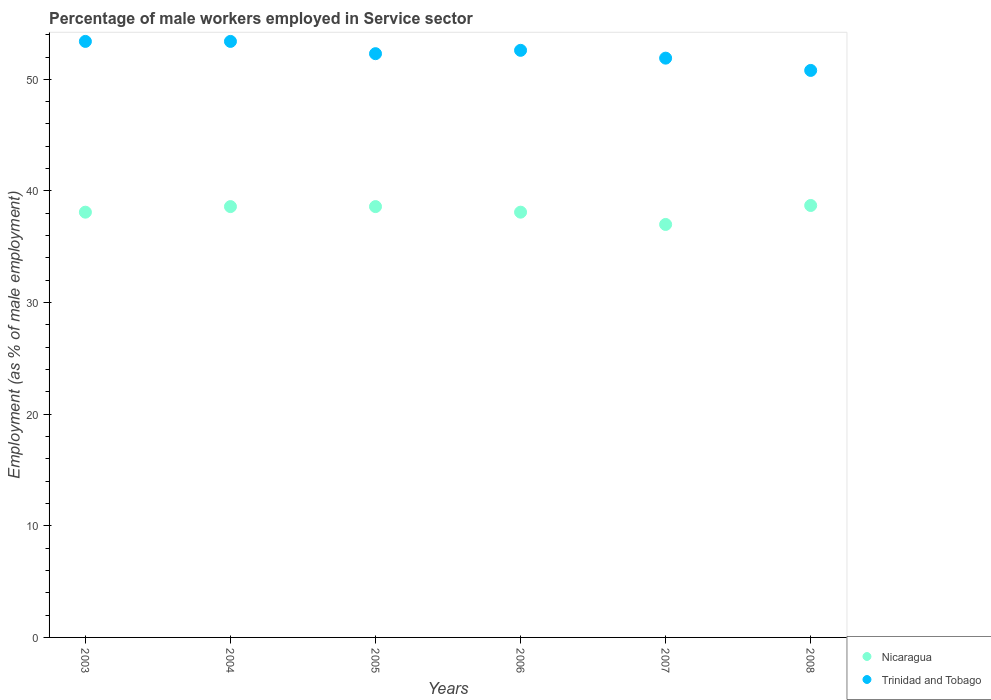How many different coloured dotlines are there?
Provide a succinct answer. 2. Across all years, what is the maximum percentage of male workers employed in Service sector in Nicaragua?
Keep it short and to the point. 38.7. Across all years, what is the minimum percentage of male workers employed in Service sector in Trinidad and Tobago?
Your answer should be compact. 50.8. In which year was the percentage of male workers employed in Service sector in Trinidad and Tobago maximum?
Ensure brevity in your answer.  2003. In which year was the percentage of male workers employed in Service sector in Nicaragua minimum?
Ensure brevity in your answer.  2007. What is the total percentage of male workers employed in Service sector in Trinidad and Tobago in the graph?
Give a very brief answer. 314.4. What is the difference between the percentage of male workers employed in Service sector in Trinidad and Tobago in 2004 and that in 2006?
Keep it short and to the point. 0.8. What is the average percentage of male workers employed in Service sector in Nicaragua per year?
Your response must be concise. 38.18. In the year 2008, what is the difference between the percentage of male workers employed in Service sector in Trinidad and Tobago and percentage of male workers employed in Service sector in Nicaragua?
Ensure brevity in your answer.  12.1. What is the ratio of the percentage of male workers employed in Service sector in Trinidad and Tobago in 2007 to that in 2008?
Your answer should be very brief. 1.02. What is the difference between the highest and the second highest percentage of male workers employed in Service sector in Trinidad and Tobago?
Your answer should be compact. 0. What is the difference between the highest and the lowest percentage of male workers employed in Service sector in Nicaragua?
Ensure brevity in your answer.  1.7. Does the percentage of male workers employed in Service sector in Nicaragua monotonically increase over the years?
Offer a very short reply. No. What is the difference between two consecutive major ticks on the Y-axis?
Your answer should be very brief. 10. How are the legend labels stacked?
Keep it short and to the point. Vertical. What is the title of the graph?
Your answer should be compact. Percentage of male workers employed in Service sector. What is the label or title of the X-axis?
Provide a succinct answer. Years. What is the label or title of the Y-axis?
Offer a terse response. Employment (as % of male employment). What is the Employment (as % of male employment) in Nicaragua in 2003?
Offer a terse response. 38.1. What is the Employment (as % of male employment) in Trinidad and Tobago in 2003?
Make the answer very short. 53.4. What is the Employment (as % of male employment) of Nicaragua in 2004?
Make the answer very short. 38.6. What is the Employment (as % of male employment) of Trinidad and Tobago in 2004?
Offer a terse response. 53.4. What is the Employment (as % of male employment) of Nicaragua in 2005?
Provide a short and direct response. 38.6. What is the Employment (as % of male employment) of Trinidad and Tobago in 2005?
Make the answer very short. 52.3. What is the Employment (as % of male employment) in Nicaragua in 2006?
Your answer should be compact. 38.1. What is the Employment (as % of male employment) in Trinidad and Tobago in 2006?
Make the answer very short. 52.6. What is the Employment (as % of male employment) in Nicaragua in 2007?
Your answer should be compact. 37. What is the Employment (as % of male employment) in Trinidad and Tobago in 2007?
Offer a terse response. 51.9. What is the Employment (as % of male employment) in Nicaragua in 2008?
Provide a short and direct response. 38.7. What is the Employment (as % of male employment) in Trinidad and Tobago in 2008?
Keep it short and to the point. 50.8. Across all years, what is the maximum Employment (as % of male employment) in Nicaragua?
Your response must be concise. 38.7. Across all years, what is the maximum Employment (as % of male employment) of Trinidad and Tobago?
Give a very brief answer. 53.4. Across all years, what is the minimum Employment (as % of male employment) of Nicaragua?
Offer a terse response. 37. Across all years, what is the minimum Employment (as % of male employment) of Trinidad and Tobago?
Make the answer very short. 50.8. What is the total Employment (as % of male employment) in Nicaragua in the graph?
Ensure brevity in your answer.  229.1. What is the total Employment (as % of male employment) in Trinidad and Tobago in the graph?
Your answer should be very brief. 314.4. What is the difference between the Employment (as % of male employment) in Trinidad and Tobago in 2003 and that in 2004?
Offer a terse response. 0. What is the difference between the Employment (as % of male employment) of Nicaragua in 2003 and that in 2005?
Your response must be concise. -0.5. What is the difference between the Employment (as % of male employment) in Trinidad and Tobago in 2003 and that in 2005?
Your answer should be compact. 1.1. What is the difference between the Employment (as % of male employment) of Nicaragua in 2003 and that in 2006?
Your answer should be very brief. 0. What is the difference between the Employment (as % of male employment) in Trinidad and Tobago in 2003 and that in 2006?
Provide a succinct answer. 0.8. What is the difference between the Employment (as % of male employment) in Nicaragua in 2003 and that in 2007?
Provide a succinct answer. 1.1. What is the difference between the Employment (as % of male employment) in Trinidad and Tobago in 2003 and that in 2007?
Your response must be concise. 1.5. What is the difference between the Employment (as % of male employment) in Trinidad and Tobago in 2003 and that in 2008?
Ensure brevity in your answer.  2.6. What is the difference between the Employment (as % of male employment) of Nicaragua in 2004 and that in 2005?
Offer a very short reply. 0. What is the difference between the Employment (as % of male employment) in Nicaragua in 2004 and that in 2006?
Your answer should be very brief. 0.5. What is the difference between the Employment (as % of male employment) of Trinidad and Tobago in 2004 and that in 2006?
Keep it short and to the point. 0.8. What is the difference between the Employment (as % of male employment) in Nicaragua in 2004 and that in 2007?
Provide a succinct answer. 1.6. What is the difference between the Employment (as % of male employment) in Trinidad and Tobago in 2004 and that in 2007?
Provide a short and direct response. 1.5. What is the difference between the Employment (as % of male employment) in Trinidad and Tobago in 2004 and that in 2008?
Your response must be concise. 2.6. What is the difference between the Employment (as % of male employment) of Trinidad and Tobago in 2005 and that in 2006?
Your response must be concise. -0.3. What is the difference between the Employment (as % of male employment) of Nicaragua in 2005 and that in 2007?
Offer a terse response. 1.6. What is the difference between the Employment (as % of male employment) of Nicaragua in 2005 and that in 2008?
Your response must be concise. -0.1. What is the difference between the Employment (as % of male employment) in Nicaragua in 2006 and that in 2007?
Keep it short and to the point. 1.1. What is the difference between the Employment (as % of male employment) in Nicaragua in 2006 and that in 2008?
Your answer should be very brief. -0.6. What is the difference between the Employment (as % of male employment) in Nicaragua in 2003 and the Employment (as % of male employment) in Trinidad and Tobago in 2004?
Offer a terse response. -15.3. What is the difference between the Employment (as % of male employment) of Nicaragua in 2003 and the Employment (as % of male employment) of Trinidad and Tobago in 2006?
Your response must be concise. -14.5. What is the difference between the Employment (as % of male employment) of Nicaragua in 2003 and the Employment (as % of male employment) of Trinidad and Tobago in 2007?
Give a very brief answer. -13.8. What is the difference between the Employment (as % of male employment) of Nicaragua in 2003 and the Employment (as % of male employment) of Trinidad and Tobago in 2008?
Provide a succinct answer. -12.7. What is the difference between the Employment (as % of male employment) of Nicaragua in 2004 and the Employment (as % of male employment) of Trinidad and Tobago in 2005?
Ensure brevity in your answer.  -13.7. What is the difference between the Employment (as % of male employment) of Nicaragua in 2004 and the Employment (as % of male employment) of Trinidad and Tobago in 2006?
Your response must be concise. -14. What is the difference between the Employment (as % of male employment) of Nicaragua in 2004 and the Employment (as % of male employment) of Trinidad and Tobago in 2007?
Give a very brief answer. -13.3. What is the difference between the Employment (as % of male employment) in Nicaragua in 2004 and the Employment (as % of male employment) in Trinidad and Tobago in 2008?
Ensure brevity in your answer.  -12.2. What is the difference between the Employment (as % of male employment) in Nicaragua in 2007 and the Employment (as % of male employment) in Trinidad and Tobago in 2008?
Offer a terse response. -13.8. What is the average Employment (as % of male employment) in Nicaragua per year?
Provide a short and direct response. 38.18. What is the average Employment (as % of male employment) in Trinidad and Tobago per year?
Make the answer very short. 52.4. In the year 2003, what is the difference between the Employment (as % of male employment) in Nicaragua and Employment (as % of male employment) in Trinidad and Tobago?
Provide a succinct answer. -15.3. In the year 2004, what is the difference between the Employment (as % of male employment) of Nicaragua and Employment (as % of male employment) of Trinidad and Tobago?
Your response must be concise. -14.8. In the year 2005, what is the difference between the Employment (as % of male employment) of Nicaragua and Employment (as % of male employment) of Trinidad and Tobago?
Your response must be concise. -13.7. In the year 2006, what is the difference between the Employment (as % of male employment) of Nicaragua and Employment (as % of male employment) of Trinidad and Tobago?
Ensure brevity in your answer.  -14.5. In the year 2007, what is the difference between the Employment (as % of male employment) of Nicaragua and Employment (as % of male employment) of Trinidad and Tobago?
Make the answer very short. -14.9. In the year 2008, what is the difference between the Employment (as % of male employment) of Nicaragua and Employment (as % of male employment) of Trinidad and Tobago?
Offer a very short reply. -12.1. What is the ratio of the Employment (as % of male employment) of Nicaragua in 2003 to that in 2004?
Your response must be concise. 0.99. What is the ratio of the Employment (as % of male employment) in Trinidad and Tobago in 2003 to that in 2004?
Keep it short and to the point. 1. What is the ratio of the Employment (as % of male employment) of Nicaragua in 2003 to that in 2005?
Make the answer very short. 0.99. What is the ratio of the Employment (as % of male employment) in Trinidad and Tobago in 2003 to that in 2006?
Provide a short and direct response. 1.02. What is the ratio of the Employment (as % of male employment) of Nicaragua in 2003 to that in 2007?
Give a very brief answer. 1.03. What is the ratio of the Employment (as % of male employment) of Trinidad and Tobago in 2003 to that in 2007?
Make the answer very short. 1.03. What is the ratio of the Employment (as % of male employment) of Nicaragua in 2003 to that in 2008?
Your answer should be compact. 0.98. What is the ratio of the Employment (as % of male employment) of Trinidad and Tobago in 2003 to that in 2008?
Make the answer very short. 1.05. What is the ratio of the Employment (as % of male employment) of Nicaragua in 2004 to that in 2005?
Make the answer very short. 1. What is the ratio of the Employment (as % of male employment) in Nicaragua in 2004 to that in 2006?
Your answer should be very brief. 1.01. What is the ratio of the Employment (as % of male employment) in Trinidad and Tobago in 2004 to that in 2006?
Offer a terse response. 1.02. What is the ratio of the Employment (as % of male employment) of Nicaragua in 2004 to that in 2007?
Keep it short and to the point. 1.04. What is the ratio of the Employment (as % of male employment) of Trinidad and Tobago in 2004 to that in 2007?
Your response must be concise. 1.03. What is the ratio of the Employment (as % of male employment) of Trinidad and Tobago in 2004 to that in 2008?
Make the answer very short. 1.05. What is the ratio of the Employment (as % of male employment) of Nicaragua in 2005 to that in 2006?
Keep it short and to the point. 1.01. What is the ratio of the Employment (as % of male employment) of Nicaragua in 2005 to that in 2007?
Your answer should be very brief. 1.04. What is the ratio of the Employment (as % of male employment) in Trinidad and Tobago in 2005 to that in 2007?
Your answer should be compact. 1.01. What is the ratio of the Employment (as % of male employment) in Nicaragua in 2005 to that in 2008?
Provide a short and direct response. 1. What is the ratio of the Employment (as % of male employment) of Trinidad and Tobago in 2005 to that in 2008?
Keep it short and to the point. 1.03. What is the ratio of the Employment (as % of male employment) of Nicaragua in 2006 to that in 2007?
Provide a short and direct response. 1.03. What is the ratio of the Employment (as % of male employment) in Trinidad and Tobago in 2006 to that in 2007?
Give a very brief answer. 1.01. What is the ratio of the Employment (as % of male employment) of Nicaragua in 2006 to that in 2008?
Provide a short and direct response. 0.98. What is the ratio of the Employment (as % of male employment) of Trinidad and Tobago in 2006 to that in 2008?
Make the answer very short. 1.04. What is the ratio of the Employment (as % of male employment) in Nicaragua in 2007 to that in 2008?
Offer a terse response. 0.96. What is the ratio of the Employment (as % of male employment) of Trinidad and Tobago in 2007 to that in 2008?
Offer a very short reply. 1.02. What is the difference between the highest and the second highest Employment (as % of male employment) in Nicaragua?
Give a very brief answer. 0.1. What is the difference between the highest and the lowest Employment (as % of male employment) of Nicaragua?
Make the answer very short. 1.7. What is the difference between the highest and the lowest Employment (as % of male employment) of Trinidad and Tobago?
Your response must be concise. 2.6. 